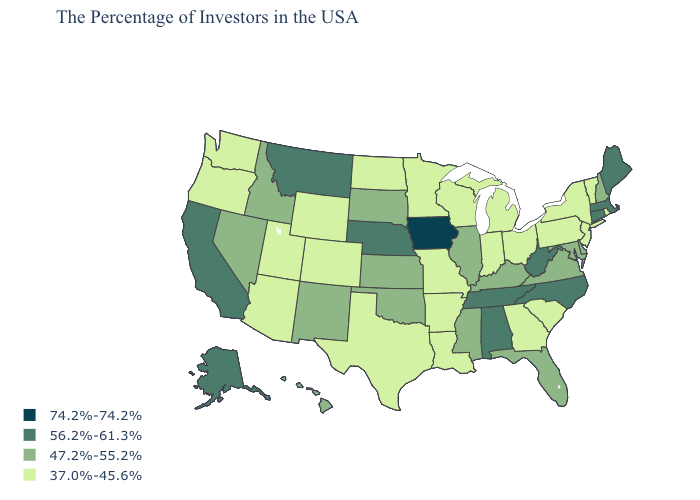What is the highest value in the South ?
Short answer required. 56.2%-61.3%. Does the map have missing data?
Quick response, please. No. Which states have the lowest value in the South?
Give a very brief answer. South Carolina, Georgia, Louisiana, Arkansas, Texas. Is the legend a continuous bar?
Be succinct. No. What is the value of Alabama?
Answer briefly. 56.2%-61.3%. Name the states that have a value in the range 56.2%-61.3%?
Answer briefly. Maine, Massachusetts, Connecticut, North Carolina, West Virginia, Alabama, Tennessee, Nebraska, Montana, California, Alaska. Does the first symbol in the legend represent the smallest category?
Concise answer only. No. What is the highest value in the MidWest ?
Write a very short answer. 74.2%-74.2%. Which states hav the highest value in the West?
Write a very short answer. Montana, California, Alaska. Which states have the lowest value in the Northeast?
Quick response, please. Rhode Island, Vermont, New York, New Jersey, Pennsylvania. Does the first symbol in the legend represent the smallest category?
Quick response, please. No. Name the states that have a value in the range 47.2%-55.2%?
Give a very brief answer. New Hampshire, Delaware, Maryland, Virginia, Florida, Kentucky, Illinois, Mississippi, Kansas, Oklahoma, South Dakota, New Mexico, Idaho, Nevada, Hawaii. What is the highest value in the USA?
Answer briefly. 74.2%-74.2%. Among the states that border North Dakota , which have the lowest value?
Write a very short answer. Minnesota. Among the states that border Virginia , which have the highest value?
Give a very brief answer. North Carolina, West Virginia, Tennessee. 